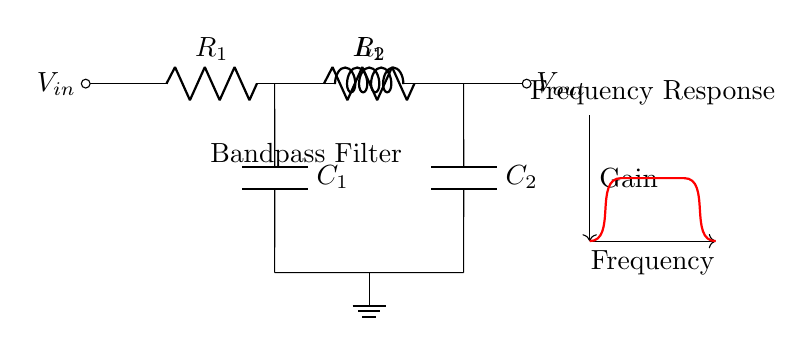What is the input voltage of the circuit? The input voltage is represented by \( V_{in} \), indicated at the left side of the circuit diagram.
Answer: \( V_{in} \) How many resistors are in the circuit? There are two resistors present in the circuit, labeled as \( R_1 \) and \( R_2 \).
Answer: 2 What is the function of this circuit? The circuit functions as a bandpass filter, which allows certain frequency ranges to pass while attenuating others. This is indicated by the label in the diagram.
Answer: Bandpass Filter Which components are in parallel in the circuit? The components in parallel are \( R_2 \), \( C_1 \), and \( L_1 \) connected to node 3, illustrated in the circuit diagram.
Answer: \( R_2, C_1, L_1 \) What is the output voltage of the circuit? The output voltage is denoted by \( V_{out} \), indicated at the right side of the circuit diagram.
Answer: \( V_{out} \) Which components affect the frequency response? The frequency response is affected by the inductor \( L_1 \) and capacitors \( C_1 \) and \( C_2 \) because their impedance characteristics determine the filter behavior based on frequency.
Answer: \( L_1, C_1, C_2 \) What is the effect of increasing \( R_1 \) on the circuit? Increasing \( R_1 \) will decrease the overall current flowing into the circuit, thus affecting the gain and possibly shifting the frequency response characteristics further altering the filter behavior.
Answer: Decrease gain 